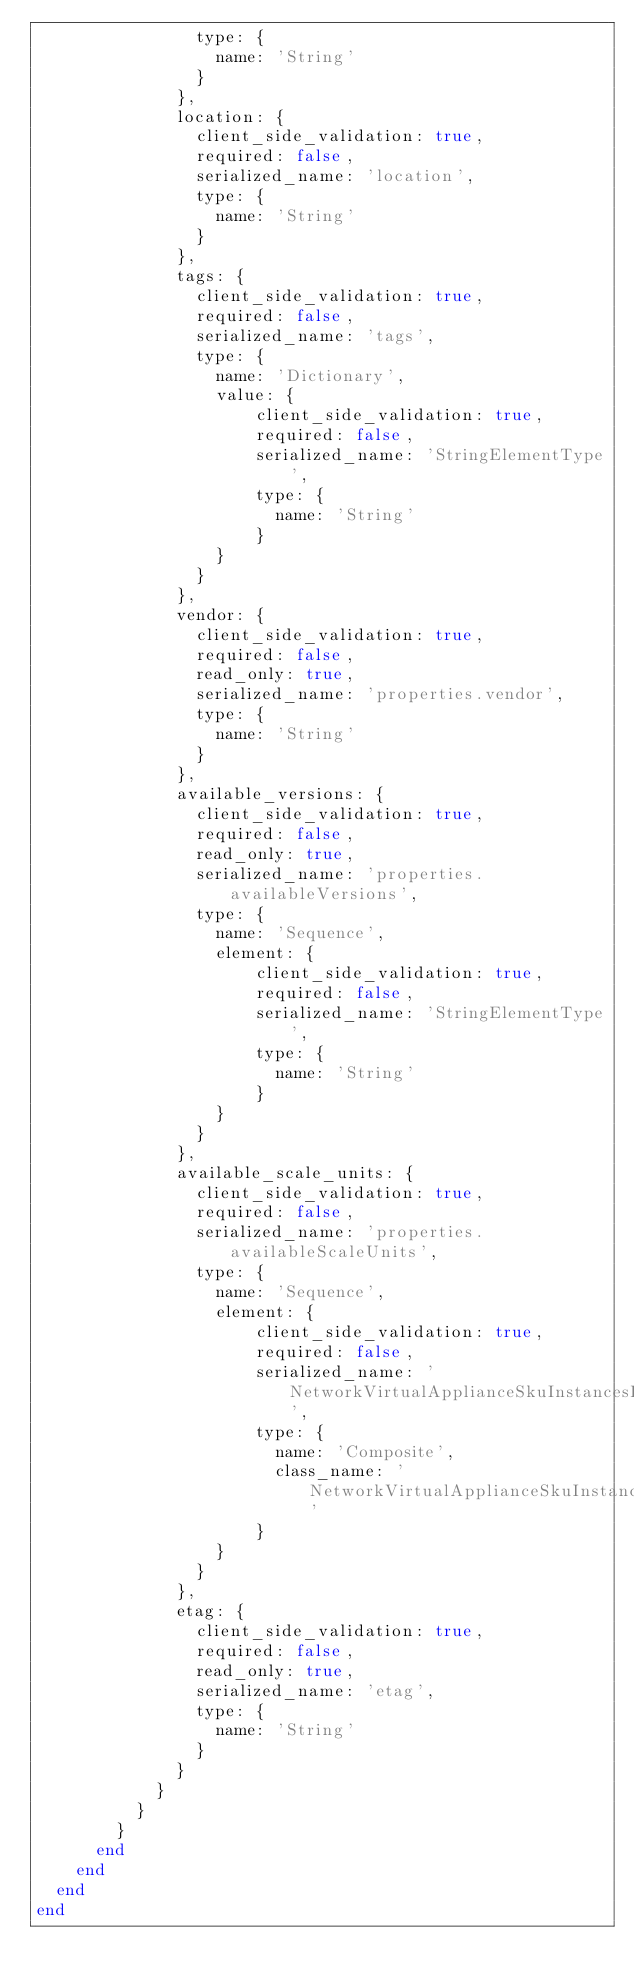Convert code to text. <code><loc_0><loc_0><loc_500><loc_500><_Ruby_>                type: {
                  name: 'String'
                }
              },
              location: {
                client_side_validation: true,
                required: false,
                serialized_name: 'location',
                type: {
                  name: 'String'
                }
              },
              tags: {
                client_side_validation: true,
                required: false,
                serialized_name: 'tags',
                type: {
                  name: 'Dictionary',
                  value: {
                      client_side_validation: true,
                      required: false,
                      serialized_name: 'StringElementType',
                      type: {
                        name: 'String'
                      }
                  }
                }
              },
              vendor: {
                client_side_validation: true,
                required: false,
                read_only: true,
                serialized_name: 'properties.vendor',
                type: {
                  name: 'String'
                }
              },
              available_versions: {
                client_side_validation: true,
                required: false,
                read_only: true,
                serialized_name: 'properties.availableVersions',
                type: {
                  name: 'Sequence',
                  element: {
                      client_side_validation: true,
                      required: false,
                      serialized_name: 'StringElementType',
                      type: {
                        name: 'String'
                      }
                  }
                }
              },
              available_scale_units: {
                client_side_validation: true,
                required: false,
                serialized_name: 'properties.availableScaleUnits',
                type: {
                  name: 'Sequence',
                  element: {
                      client_side_validation: true,
                      required: false,
                      serialized_name: 'NetworkVirtualApplianceSkuInstancesElementType',
                      type: {
                        name: 'Composite',
                        class_name: 'NetworkVirtualApplianceSkuInstances'
                      }
                  }
                }
              },
              etag: {
                client_side_validation: true,
                required: false,
                read_only: true,
                serialized_name: 'etag',
                type: {
                  name: 'String'
                }
              }
            }
          }
        }
      end
    end
  end
end
</code> 